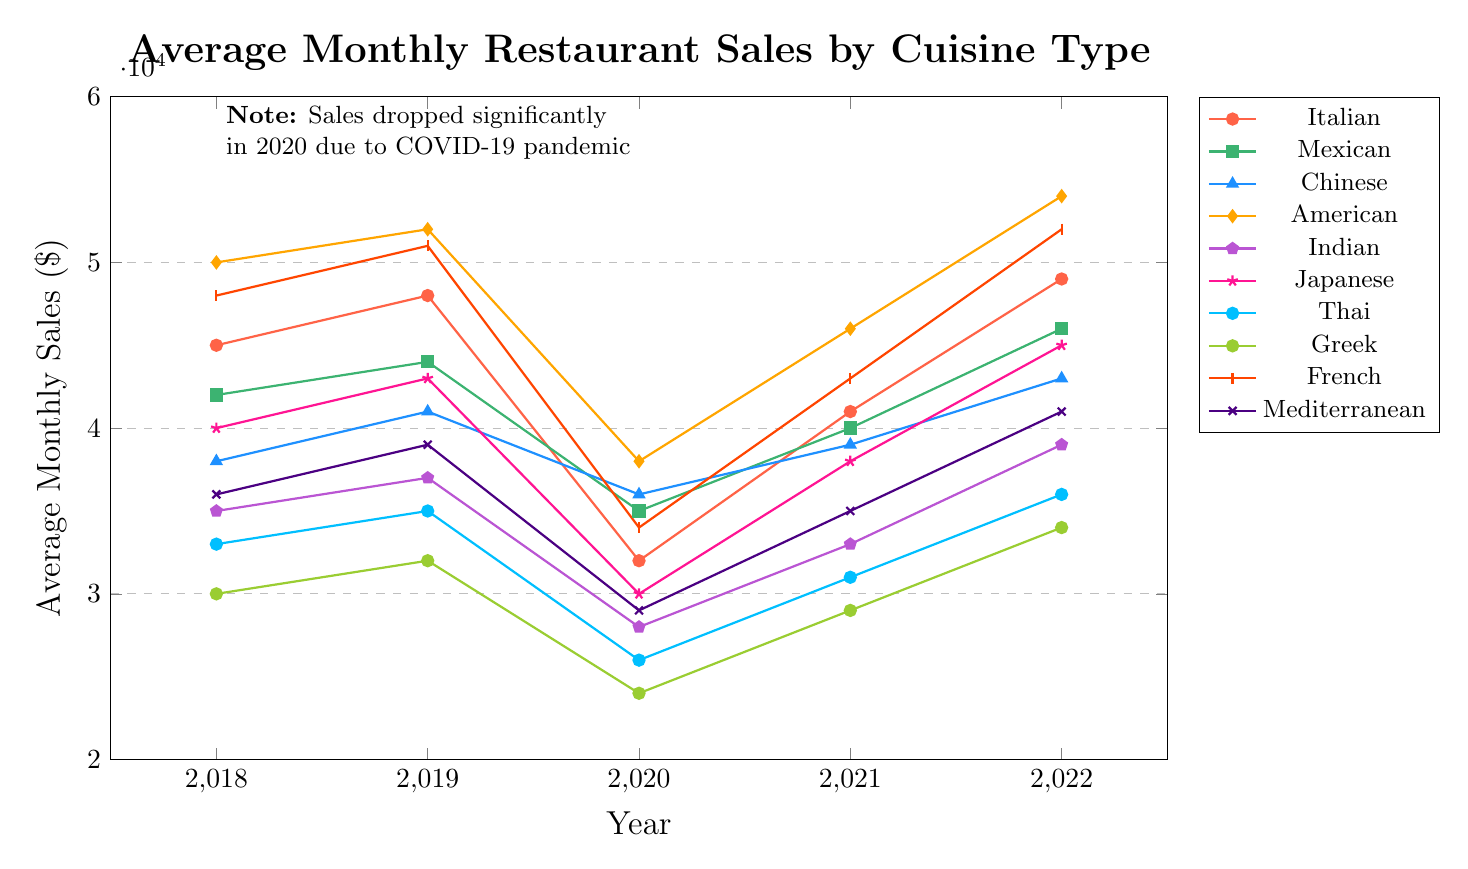What cuisine type had the highest average monthly sales in 2022? To find the cuisine type with the highest average monthly sales in 2022, look at the y-values for the year 2022. The American cuisine had the highest value at $54,000.
Answer: American Which cuisine type experienced the largest drop in average monthly sales between 2019 and 2020? To determine the cuisine type with the largest drop, calculate the difference between 2019 and 2020 for each cuisine type. The largest drop is for Italian cuisine, with a decrease from $48,000 to $32,000, which is a drop of $16,000.
Answer: Italian How did French cuisine's sales compare to Mediterranean cuisine's sales in 2021? Check the y-values for French and Mediterranean cuisines in 2021. French cuisine had $43,000 and Mediterranean cuisine had $35,000. French cuisine's sales were higher.
Answer: French was higher Which cuisine type had the highest average monthly sales in 2020? Identify the cuisine type with the highest average monthly sales in 2020 by looking at the data points for that year. American cuisine had the highest sales at $38,000.
Answer: American What was the average monthly sales for Japanese cuisine over the given years? Calculate the average by summing the sales for Japanese cuisine over the years: (40000 + 43000 + 30000 + 38000 + 45000) = 196000. Then, divide by the number of years, which is 5. So, 196000/5 = 39200.
Answer: 39,200 Which cuisines had sales consistently increasing from 2020 to 2022? Check the trend lines from 2020 to 2022 for all cuisines. The cuisines that have consistently increasing sales are Italian, Mexican, Chinese, American, French, Japanese, and Mediterranean.
Answer: Italian, Mexican, Chinese, American, French, Japanese, Mediterranean Compare the sales of Indian cuisine in 2018 to American cuisine in 2020. Which one was higher? Look at the y-values for Indian cuisine in 2018 ($35,000) and American cuisine in 2020 ($38,000). American cuisine in 2020 had higher sales.
Answer: American in 2020 What is the range of sales values for Thai cuisine over the five years? Determine the range by subtracting the lowest value from the highest value for Thai cuisine. The highest value is $36,000 (2022) and the lowest value is $26,000 (2020). So, the range is $36,000 - $26,000 = $10,000.
Answer: 10,000 How did the sales of American cuisine change from 2019 to 2022? To find the change in sales, subtract the 2019 value from the 2022 value for American cuisine. The sales in 2019 were $52,000 and in 2022 they were $54,000. So, the change is $54,000 - $38,000 = $16,000.
Answer: +16,000 Which year had the lowest average monthly sales overall and what significant event might explain this? Calculate the total sales for each year across all cuisines and find the lowest total. 2020 has the lowest totals across cuisines. A significant event that year is the COVID-19 pandemic, which likely explains the drop.
Answer: 2020, COVID-19 pandemic 